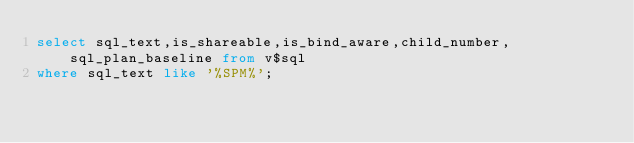<code> <loc_0><loc_0><loc_500><loc_500><_SQL_>select sql_text,is_shareable,is_bind_aware,child_number,sql_plan_baseline from v$sql
where sql_text like '%SPM%';
</code> 